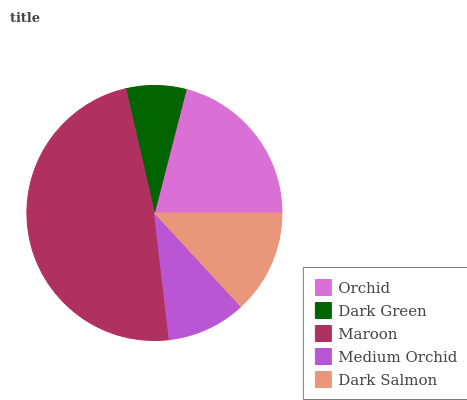Is Dark Green the minimum?
Answer yes or no. Yes. Is Maroon the maximum?
Answer yes or no. Yes. Is Maroon the minimum?
Answer yes or no. No. Is Dark Green the maximum?
Answer yes or no. No. Is Maroon greater than Dark Green?
Answer yes or no. Yes. Is Dark Green less than Maroon?
Answer yes or no. Yes. Is Dark Green greater than Maroon?
Answer yes or no. No. Is Maroon less than Dark Green?
Answer yes or no. No. Is Dark Salmon the high median?
Answer yes or no. Yes. Is Dark Salmon the low median?
Answer yes or no. Yes. Is Maroon the high median?
Answer yes or no. No. Is Medium Orchid the low median?
Answer yes or no. No. 